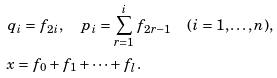<formula> <loc_0><loc_0><loc_500><loc_500>& q _ { i } = f _ { 2 i } , \quad p _ { i } = \sum _ { r = 1 } ^ { i } f _ { 2 r - 1 } \quad ( i = 1 , \dots , n ) , \\ & x = f _ { 0 } + f _ { 1 } + \cdots + f _ { l } .</formula> 